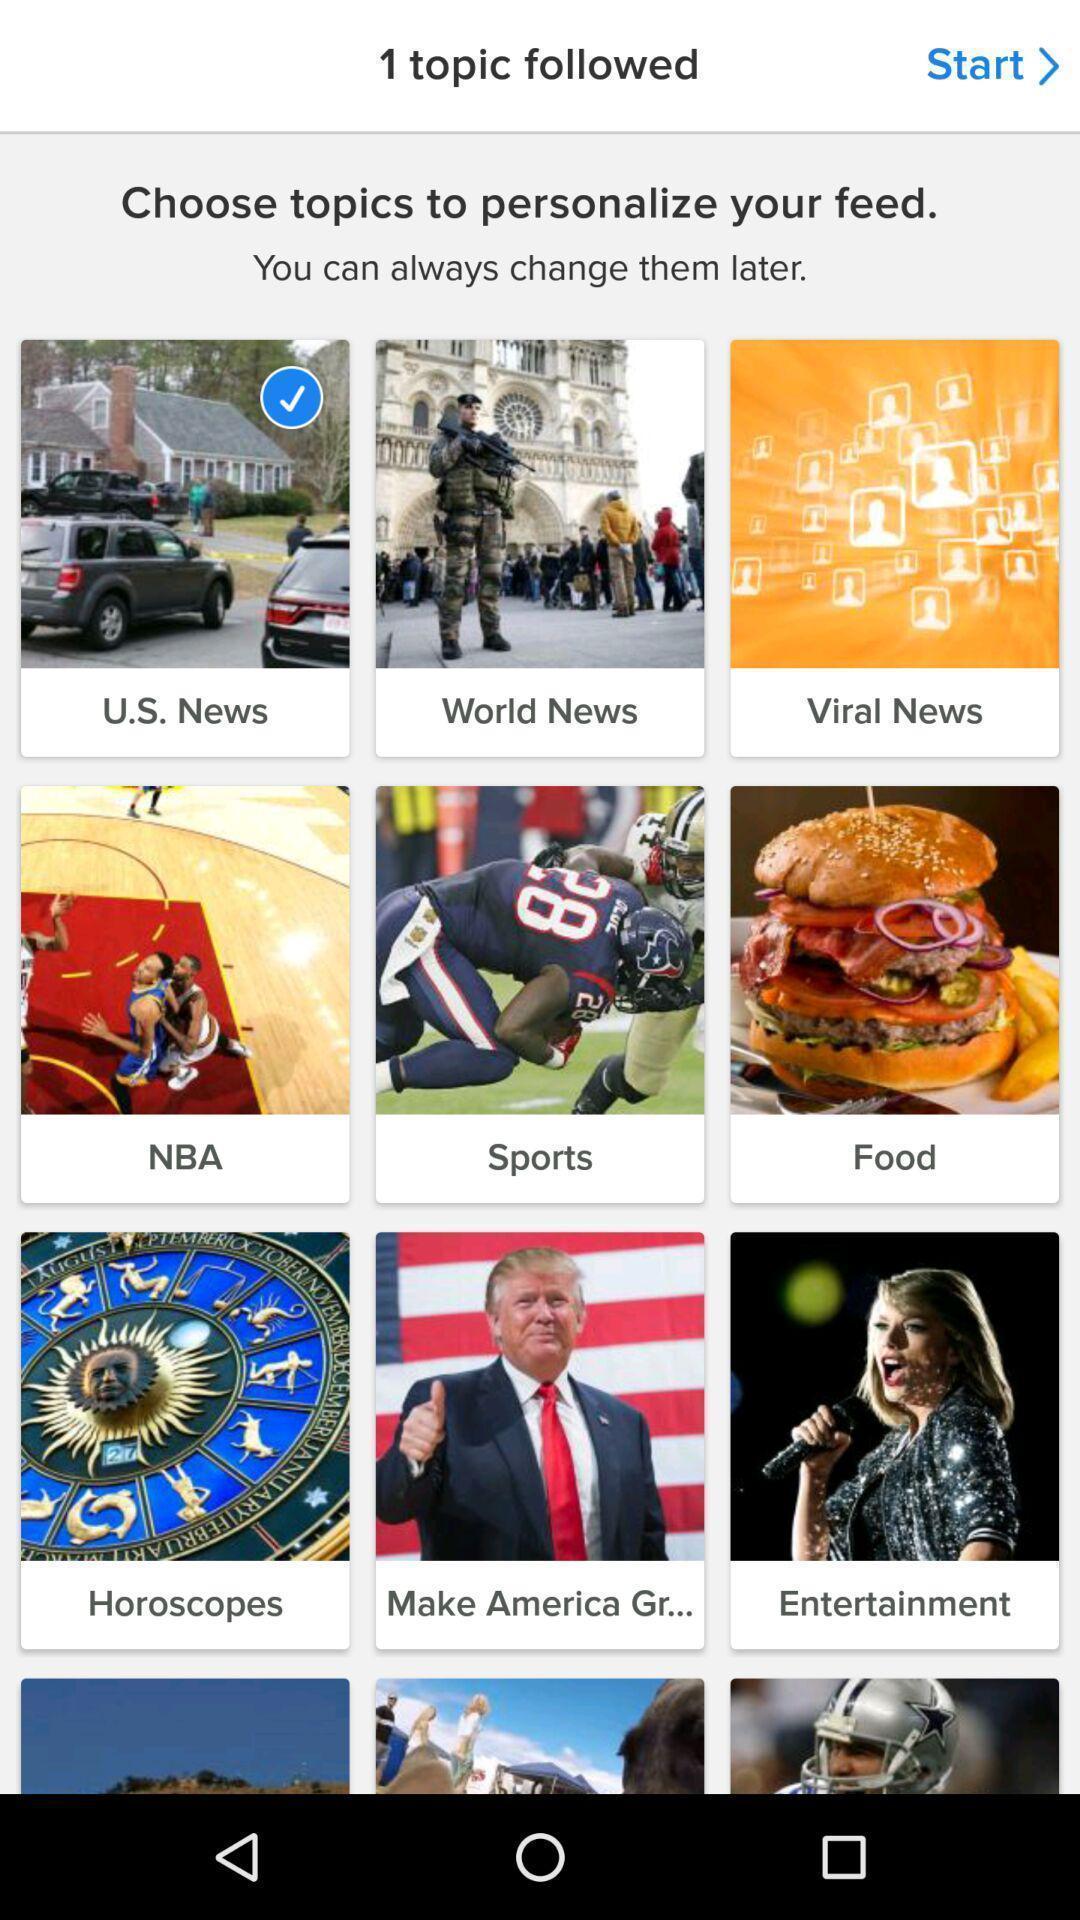Explain what's happening in this screen capture. Screen showing choose topics to personalize your feed. 